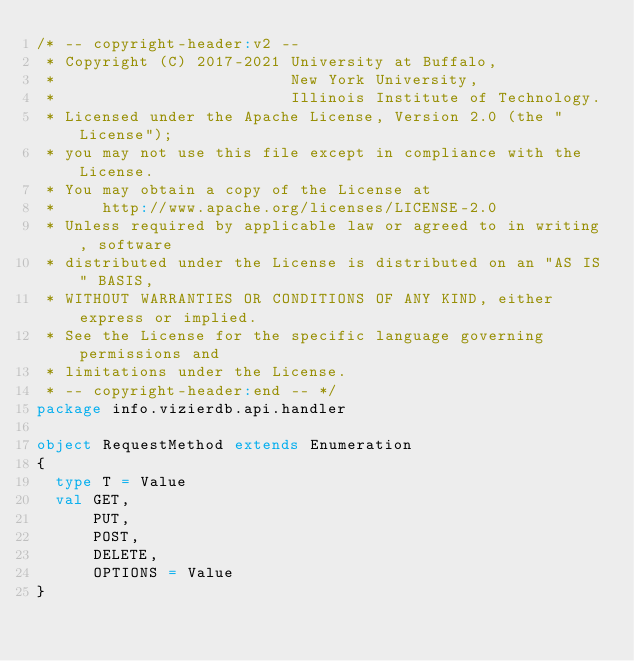Convert code to text. <code><loc_0><loc_0><loc_500><loc_500><_Scala_>/* -- copyright-header:v2 --
 * Copyright (C) 2017-2021 University at Buffalo,
 *                         New York University,
 *                         Illinois Institute of Technology.
 * Licensed under the Apache License, Version 2.0 (the "License");
 * you may not use this file except in compliance with the License.
 * You may obtain a copy of the License at
 *     http://www.apache.org/licenses/LICENSE-2.0
 * Unless required by applicable law or agreed to in writing, software
 * distributed under the License is distributed on an "AS IS" BASIS,
 * WITHOUT WARRANTIES OR CONDITIONS OF ANY KIND, either express or implied.
 * See the License for the specific language governing permissions and
 * limitations under the License.
 * -- copyright-header:end -- */
package info.vizierdb.api.handler

object RequestMethod extends Enumeration
{
  type T = Value
  val GET,
      PUT,
      POST,
      DELETE,
      OPTIONS = Value
}

</code> 